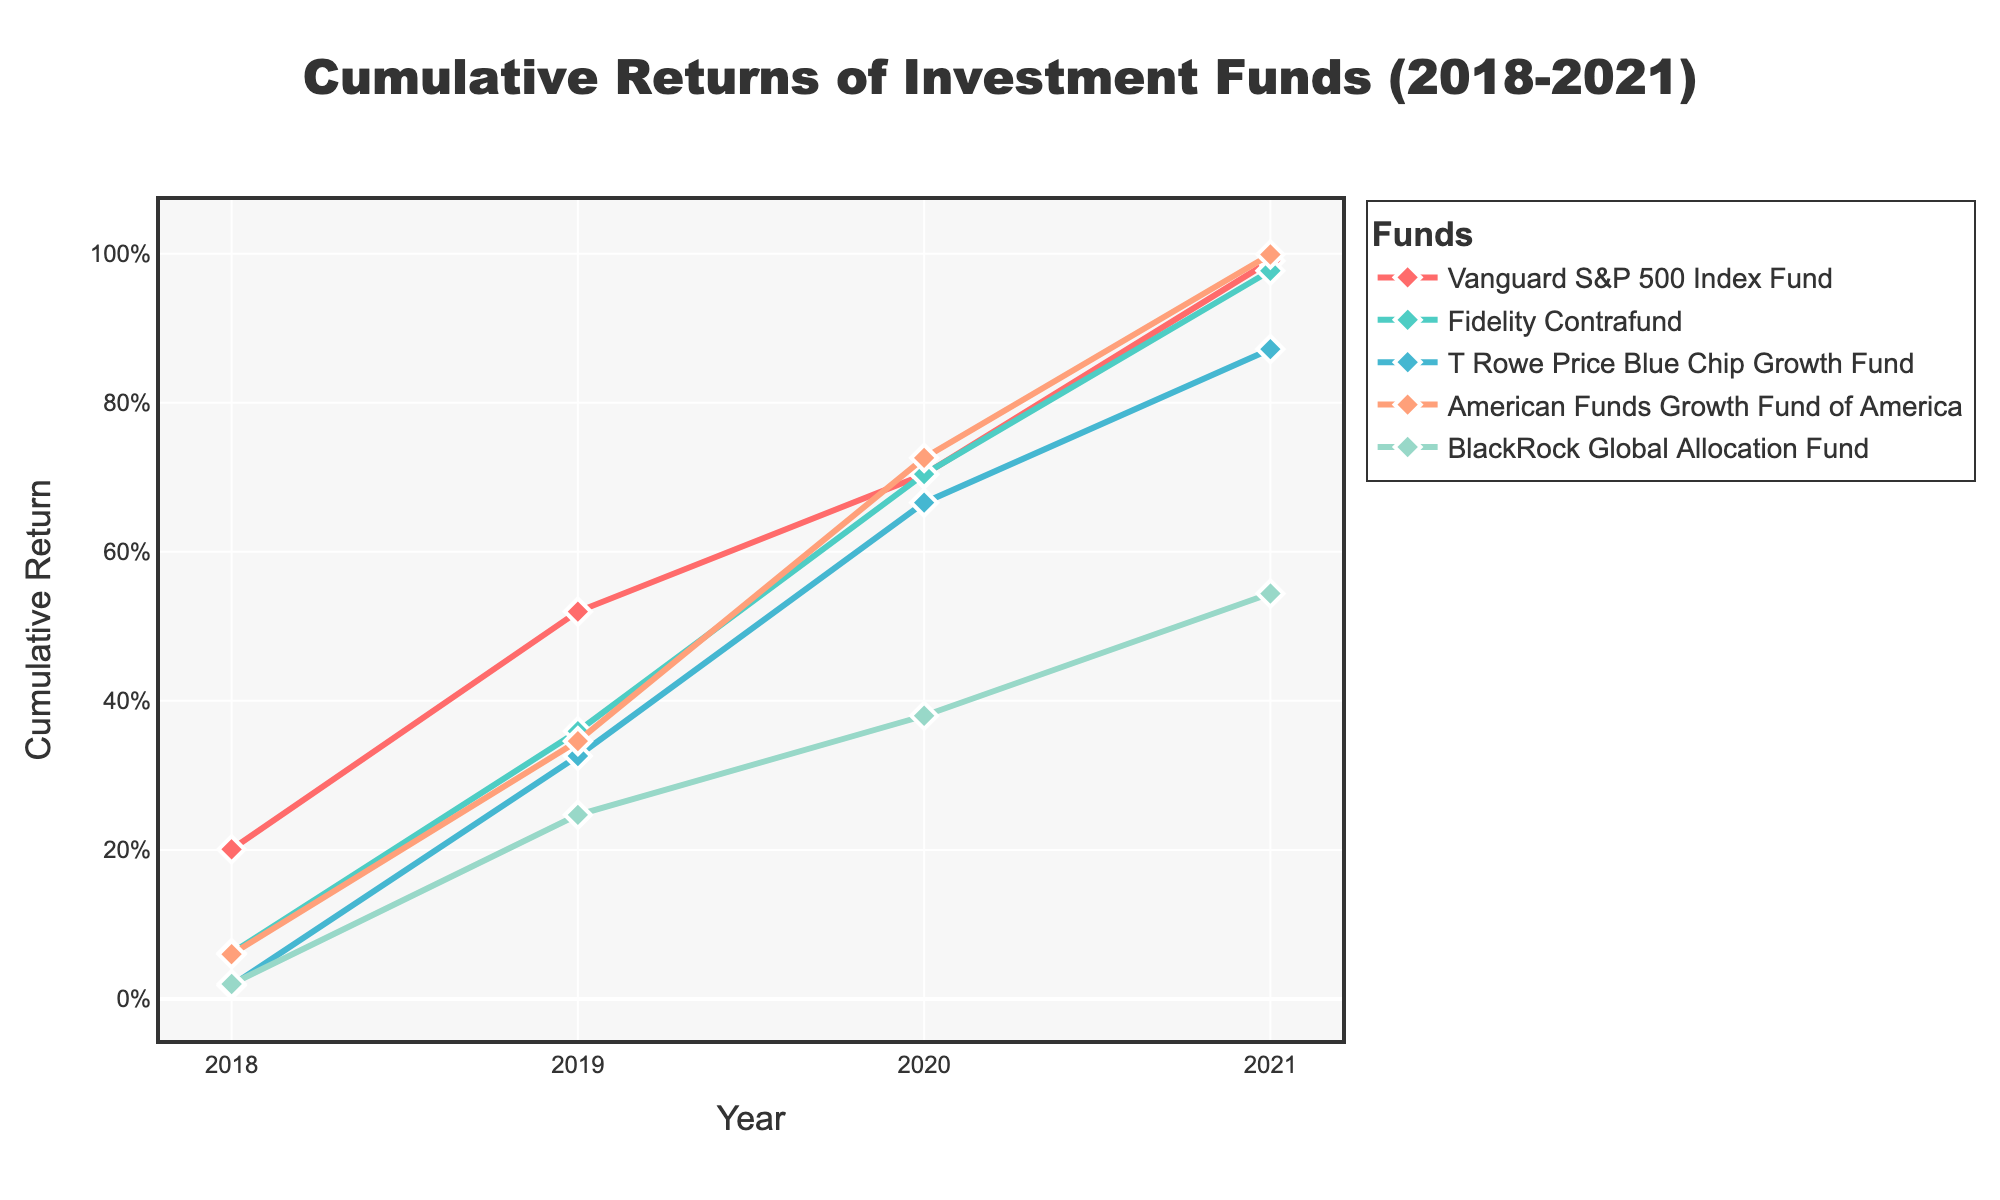What is the title of the plot? The title is displayed at the top center of the plot within the figure. By reading the title, we can easily identify the topic of the plot.
Answer: Cumulative Returns of Investment Funds (2018-2021) What are the labels of the x-axis and y-axis? The labels are typically found along each axis. The x-axis label is found at the bottom of the figure, indicating what the horizontal axis represents, and the y-axis label is on the left side, representing what the vertical axis represents.
Answer: x-axis: Year; y-axis: Cumulative Return How many funds are represented in the plot? By examining the legend, which lists all the unique fund names along with their corresponding colors, we can count the number of distinct funds presented in the plot.
Answer: 5 Which fund had the highest cumulative return in 2020? We look at the data points for the year 2020 and compare the cumulative returns of each fund. The fund with the highest point on the y-axis for this year will have the highest cumulative return.
Answer: American Funds Growth Fund of America Between which two consecutive years did the Vanguard S&P 500 Index Fund see the largest increase in cumulative return? We need to examine the line for the Vanguard S&P 500 Index Fund to find the segment where the vertical distance (cumulative return) between two consecutive points (years) is the greatest.
Answer: 2018 to 2019 Which fund had the most consistent performance over the years? We need to analyze the slope and wiggle of each fund's line. The line that's the most linear and smooth, showing the least fluctuation, indicates consistency.
Answer: BlackRock Global Allocation Fund What was the cumulative return for Fidelity Contrafund in 2021? Find the data point on the line for Fidelity Contrafund at the year 2021 and take note of its y-axis value, which represents the cumulative return.
Answer: 0.9772 Between 2018 and 2021, did any fund have a negative cumulative return? We need to check all the points for each fund from 2018 to 2021. If any line dips below the value of zero on the y-axis, it shows a negative cumulative return.
Answer: No Which two funds have the closest cumulative returns in 2021? By looking at the cluster of data points in 2021, we can compare the returns for each fund and identify the two that are nearest to each other in value.
Answer: Fidelity Contrafund and American Funds Growth Fund of America What is the average cumulative return for T. Rowe Price Blue Chip Growth Fund from 2018 to 2021? Sum the cumulative returns for the years 2018, 2019, 2020, and 2021 for T. Rowe Price Blue Chip Growth Fund and then divide by 4 to find the average.
Answer: 0.218 